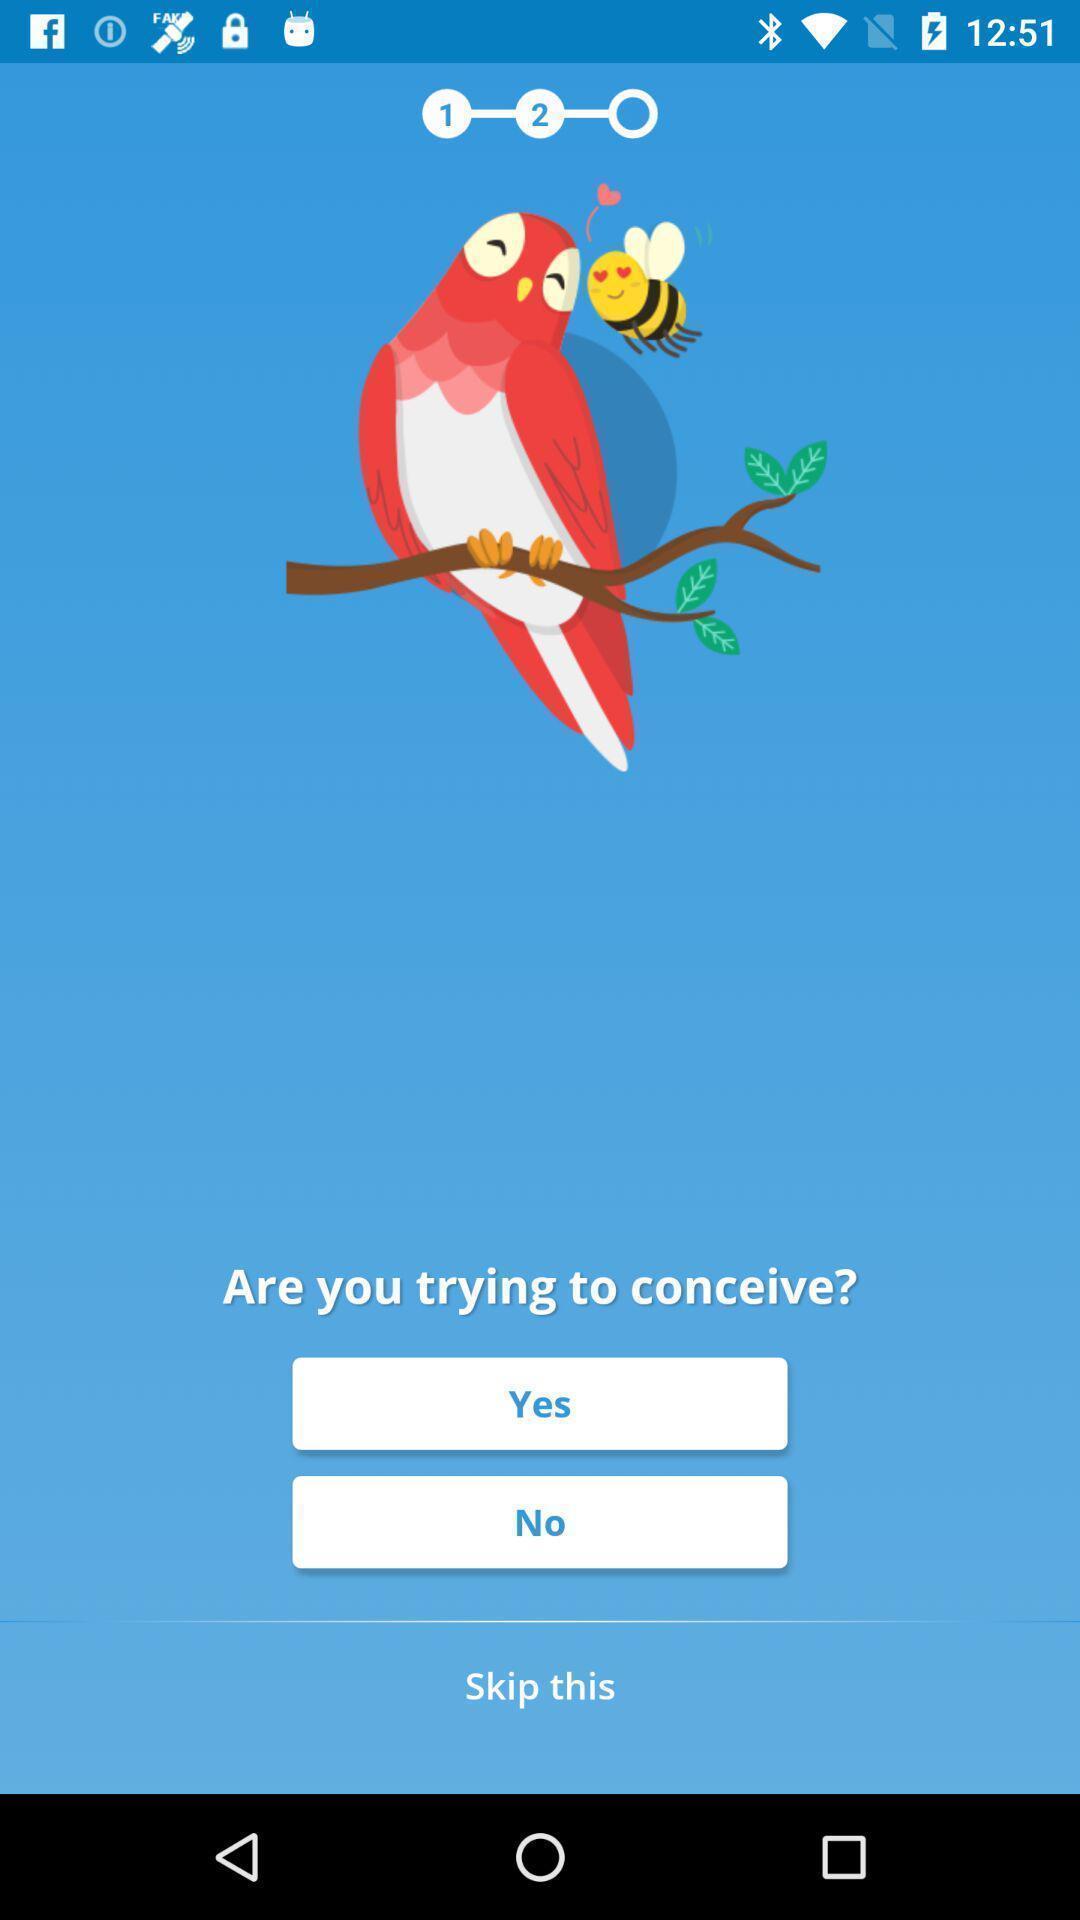Give me a narrative description of this picture. Welcome page. 